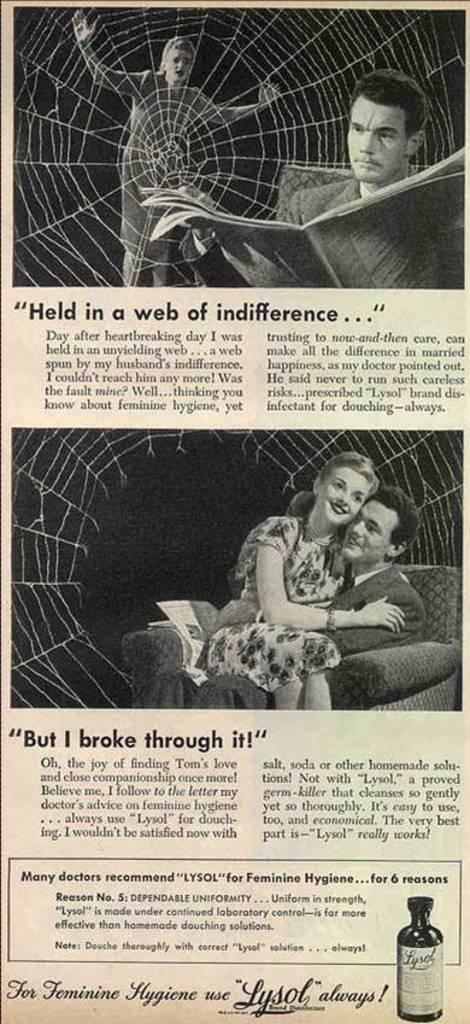In one or two sentences, can you explain what this image depicts? In this picture there are two images and there is something written below it. 